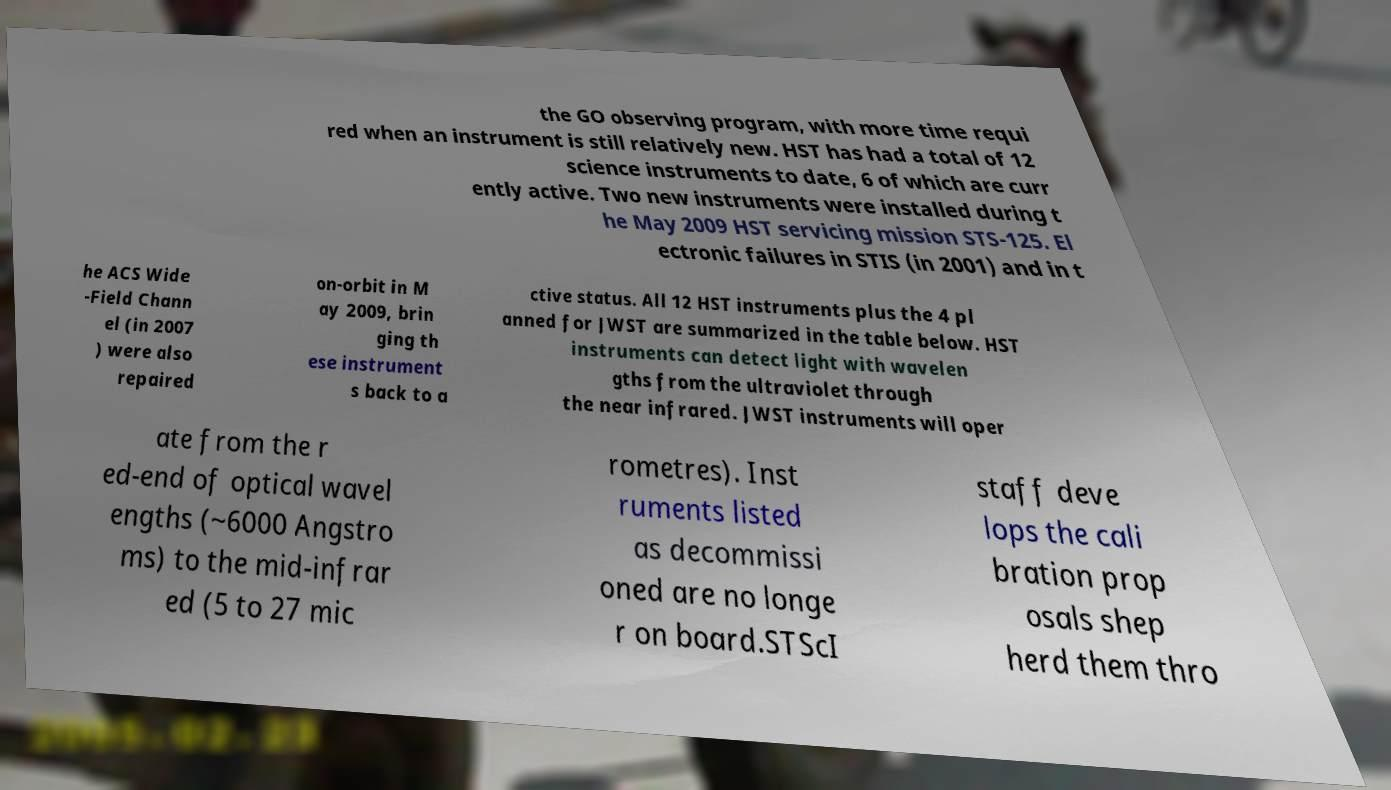There's text embedded in this image that I need extracted. Can you transcribe it verbatim? the GO observing program, with more time requi red when an instrument is still relatively new. HST has had a total of 12 science instruments to date, 6 of which are curr ently active. Two new instruments were installed during t he May 2009 HST servicing mission STS-125. El ectronic failures in STIS (in 2001) and in t he ACS Wide -Field Chann el (in 2007 ) were also repaired on-orbit in M ay 2009, brin ging th ese instrument s back to a ctive status. All 12 HST instruments plus the 4 pl anned for JWST are summarized in the table below. HST instruments can detect light with wavelen gths from the ultraviolet through the near infrared. JWST instruments will oper ate from the r ed-end of optical wavel engths (~6000 Angstro ms) to the mid-infrar ed (5 to 27 mic rometres). Inst ruments listed as decommissi oned are no longe r on board.STScI staff deve lops the cali bration prop osals shep herd them thro 